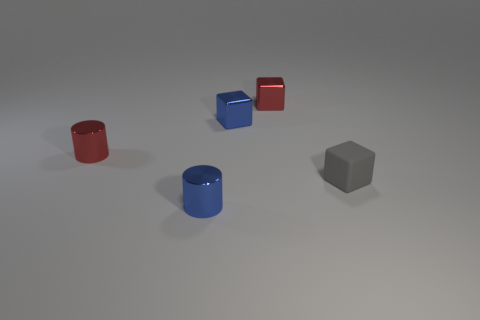Subtract all small metallic cubes. How many cubes are left? 1 Subtract all blue cylinders. How many cylinders are left? 1 Add 1 tiny blue metallic cubes. How many objects exist? 6 Subtract 0 yellow spheres. How many objects are left? 5 Subtract all cylinders. How many objects are left? 3 Subtract 2 cylinders. How many cylinders are left? 0 Subtract all gray cylinders. Subtract all gray balls. How many cylinders are left? 2 Subtract all red spheres. How many red cylinders are left? 1 Subtract all small things. Subtract all gray rubber cylinders. How many objects are left? 0 Add 2 small red objects. How many small red objects are left? 4 